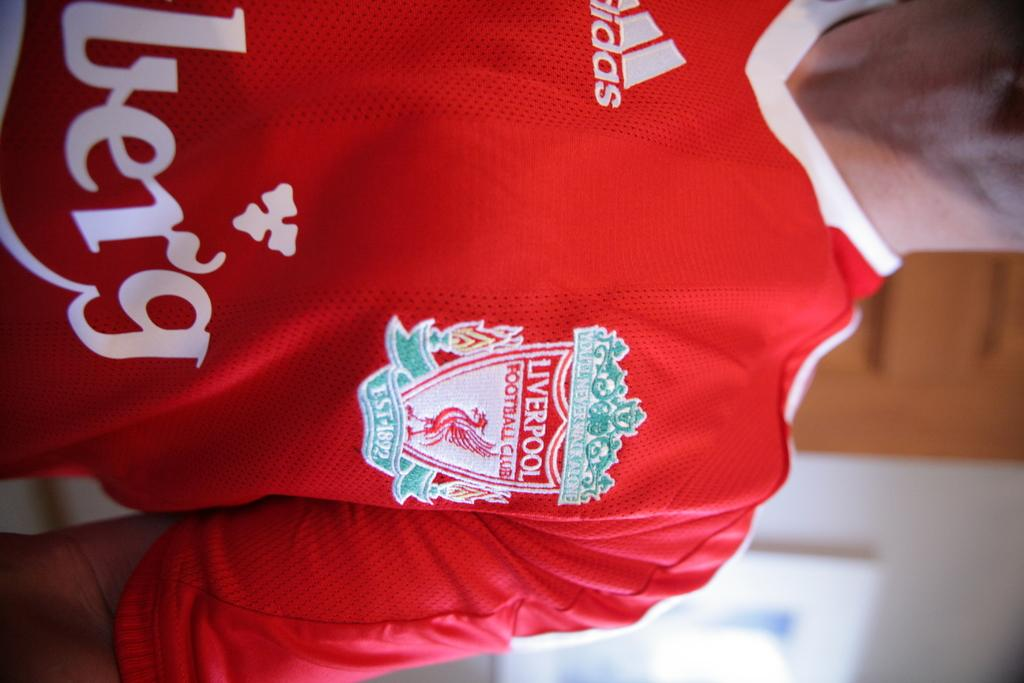<image>
Write a terse but informative summary of the picture. A man wearing a red Liverpool jersey with green embroidery on it. 